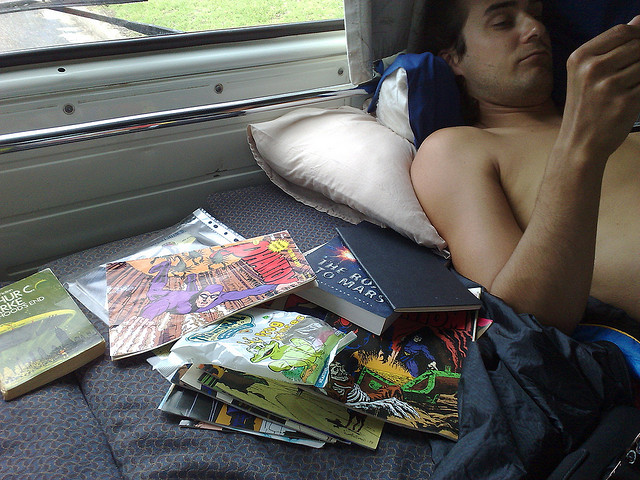Please identify all text content in this image. THE TO MARS C RKE RKE UR PHANTOY 